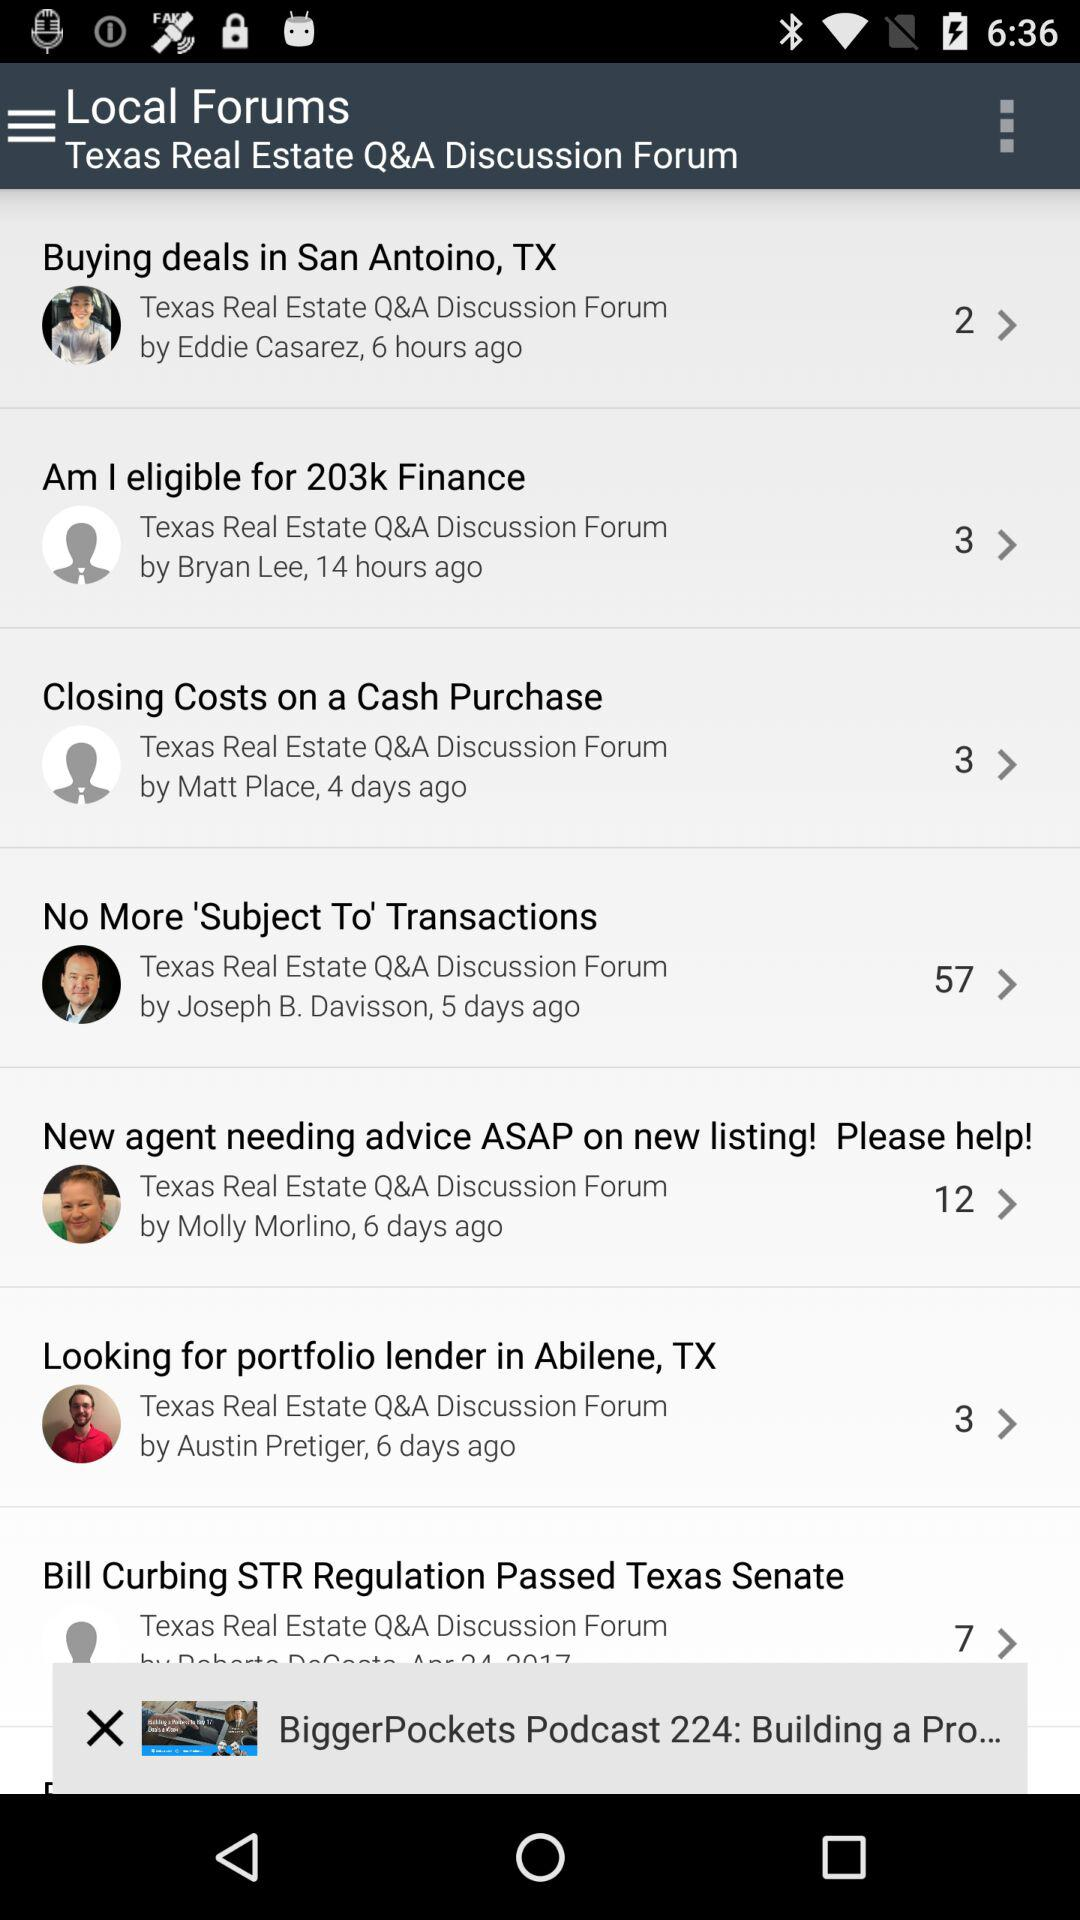Who posted the discussion named "Buying deals in San Antonio, TX" in local forums? The discussion was posted by Eddie Casarez. 